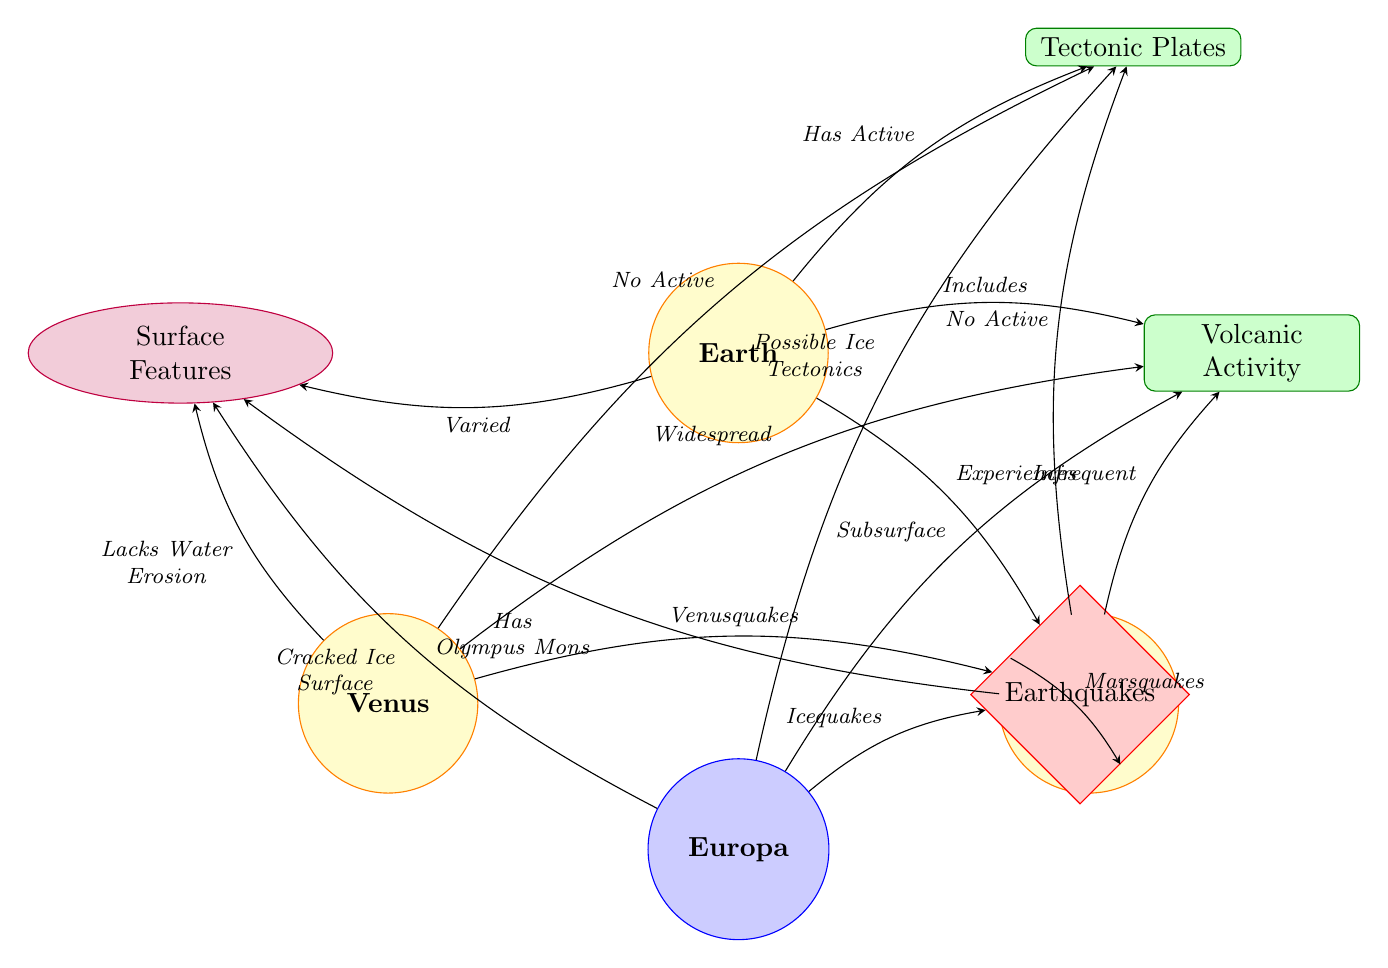What planet has active tectonic plates? The diagram indicates that Earth is the only planet listed that has active tectonic plates, as it directly connects to the "Tectonic Plates" node with the label "Has Active."
Answer: Earth Which planet has the highest volcanic activity? According to the diagram, Venus is noted for its "Widespread" volcanic activity, while Earth has "Includes," Mars has "Infrequent," and Europa is labeled as "Subsurface."
Answer: Venus What type of quakes does Europa experience? The diagram shows that Europa experiences "Icequakes," which are mentioned as a link from Europa to the "Earthquakes" node.
Answer: Icequakes How many planets are connected to the "Surface Features" property? By analyzing the diagram, it is seen that all four planets (Earth, Mars, Venus, and Europa) have a connection to the "Surface Features" node, specifically detailing various characteristics found on each.
Answer: 4 What label describes the quakes experienced by Mars? The connection from Mars to the "Earthquakes" node is labeled "Marsquakes," indicating the specific type of seismic activity occurring on Mars.
Answer: Marsquakes Which celestial body is noted for having Olympus Mons? The diagram links Mars to the "Surface Features" with the label "Has Olympus Mons," highlighting this significant feature on the Martian surface.
Answer: Mars What does Europa potentially have in terms of tectonic activity? The diagram suggests that Europa may have "Possible Ice Tectonics," indicating a potential form of tectonic behavior related to its ice-covered surface.
Answer: Possible Ice Tectonics Which planet lacks water erosion? The connection from Venus to the "Surface Features" node includes the phrase "Lacks Water Erosion," specifically indicating a characteristic absence relevant to its surface conditions.
Answer: Venus Which event is experienced by all four celestial bodies? The "Earthquakes" node is connected to all four planets, indicating that they all experience some form of seismic activity, though with different characteristics.
Answer: Earthquakes 